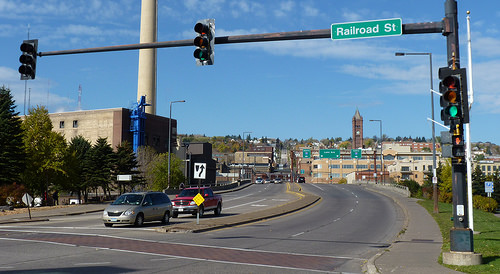<image>
Is the car on the sky? No. The car is not positioned on the sky. They may be near each other, but the car is not supported by or resting on top of the sky. Is the car in the road? Yes. The car is contained within or inside the road, showing a containment relationship. Is there a sign above the street light? No. The sign is not positioned above the street light. The vertical arrangement shows a different relationship. 